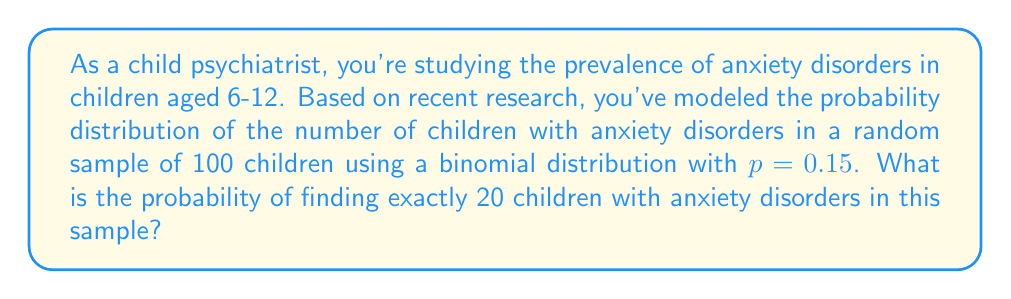What is the answer to this math problem? To solve this problem, we'll use the binomial probability mass function:

1) The binomial probability mass function is given by:

   $$P(X = k) = \binom{n}{k} p^k (1-p)^{n-k}$$

   where:
   $n$ is the number of trials (sample size)
   $k$ is the number of successes
   $p$ is the probability of success on each trial

2) In this case:
   $n = 100$ (sample size)
   $k = 20$ (number of children with anxiety disorders)
   $p = 0.15$ (probability of a child having an anxiety disorder)

3) Let's substitute these values into the formula:

   $$P(X = 20) = \binom{100}{20} (0.15)^{20} (1-0.15)^{100-20}$$

4) Simplify:
   $$P(X = 20) = \binom{100}{20} (0.15)^{20} (0.85)^{80}$$

5) Calculate the binomial coefficient:
   $$\binom{100}{20} = \frac{100!}{20!(100-20)!} = 5.36 \times 10^{20}$$

6) Now, let's compute the full probability:
   $$P(X = 20) = (5.36 \times 10^{20}) \times (0.15)^{20} \times (0.85)^{80}$$

7) Using a calculator or computer:
   $$P(X = 20) \approx 0.0584$$

Thus, the probability of finding exactly 20 children with anxiety disorders in a random sample of 100 children is approximately 0.0584 or 5.84%.
Answer: 0.0584 